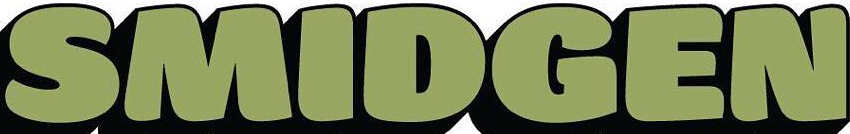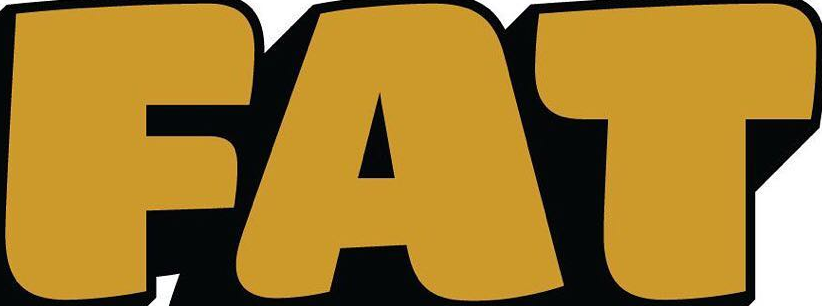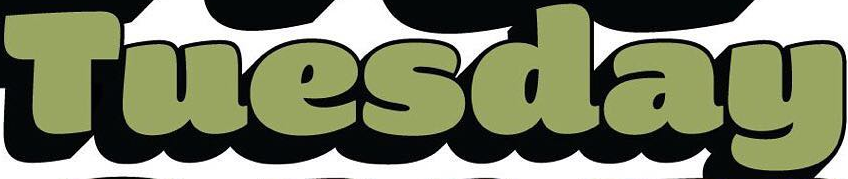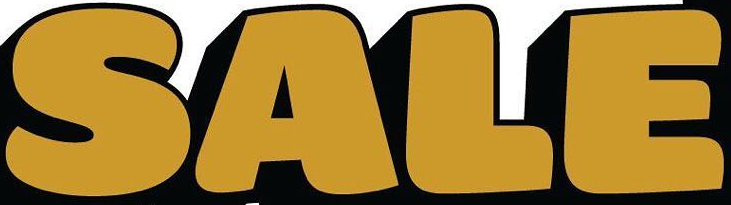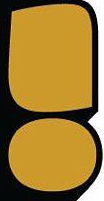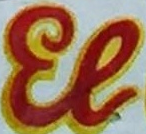What words can you see in these images in sequence, separated by a semicolon? SMIDGEN; FAT; Tuesday; SALE; !; El 